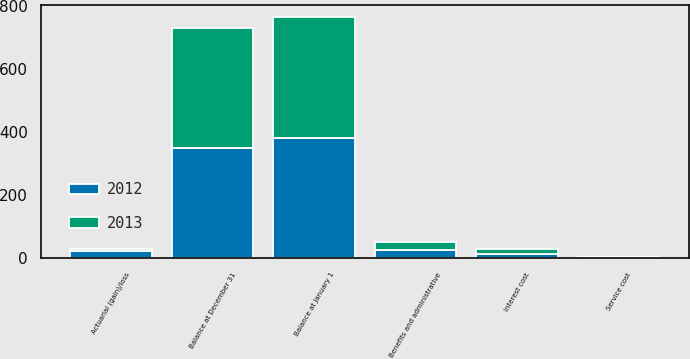Convert chart to OTSL. <chart><loc_0><loc_0><loc_500><loc_500><stacked_bar_chart><ecel><fcel>Balance at January 1<fcel>Service cost<fcel>Interest cost<fcel>Actuarial (gain)/loss<fcel>Benefits and administrative<fcel>Balance at December 31<nl><fcel>2012<fcel>380.7<fcel>3.1<fcel>14.7<fcel>22.1<fcel>26.7<fcel>349.7<nl><fcel>2013<fcel>383.2<fcel>2.4<fcel>14.9<fcel>5.8<fcel>25.6<fcel>380.7<nl></chart> 